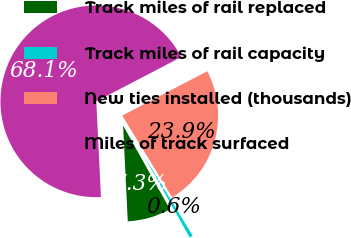<chart> <loc_0><loc_0><loc_500><loc_500><pie_chart><fcel>Track miles of rail replaced<fcel>Track miles of rail capacity<fcel>New ties installed (thousands)<fcel>Miles of track surfaced<nl><fcel>7.35%<fcel>0.6%<fcel>23.93%<fcel>68.12%<nl></chart> 